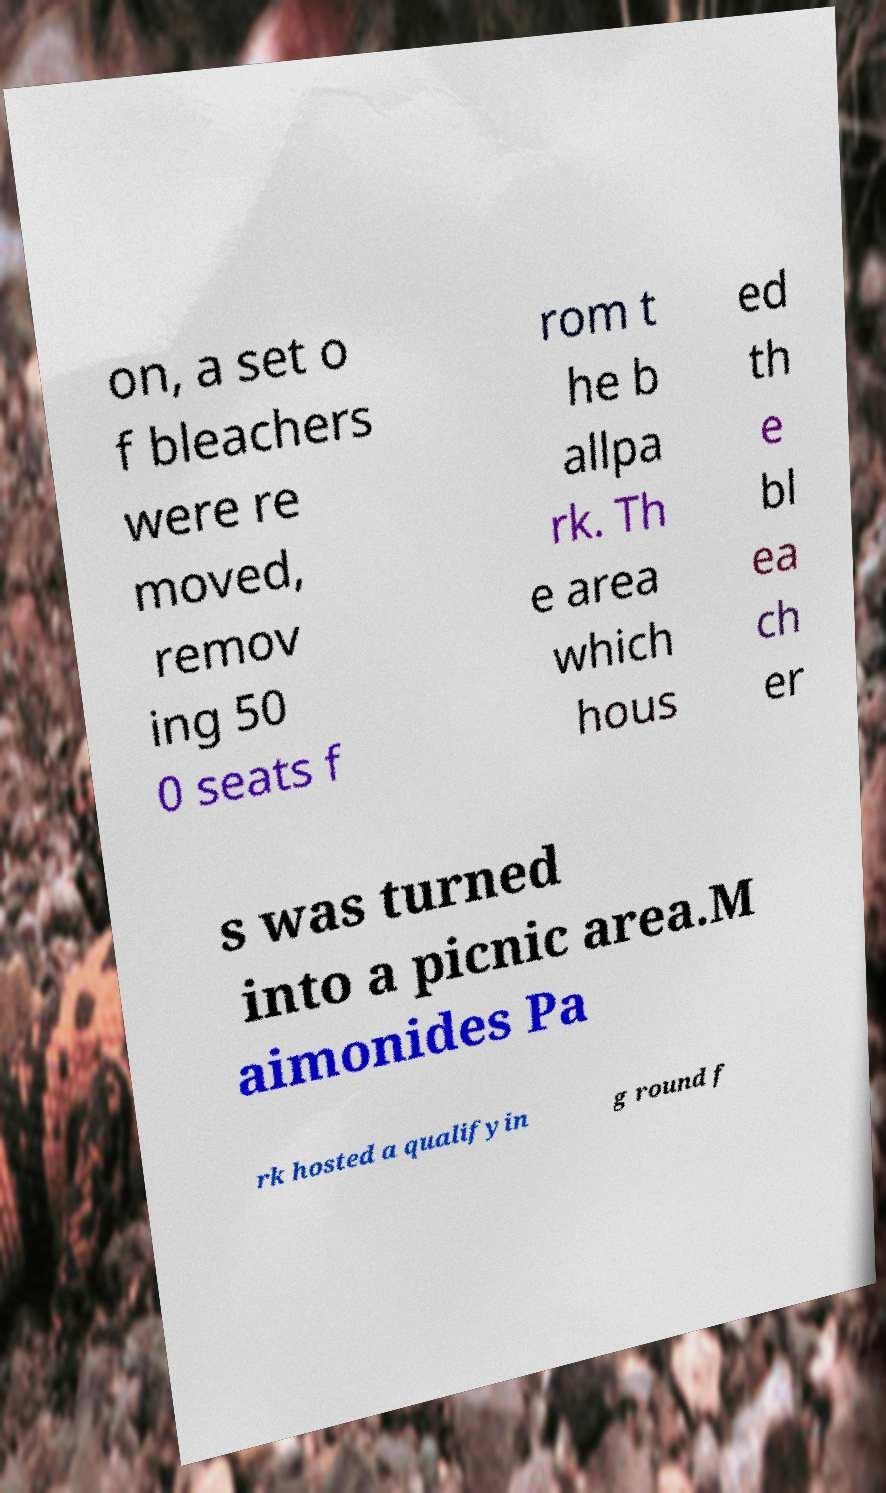I need the written content from this picture converted into text. Can you do that? on, a set o f bleachers were re moved, remov ing 50 0 seats f rom t he b allpa rk. Th e area which hous ed th e bl ea ch er s was turned into a picnic area.M aimonides Pa rk hosted a qualifyin g round f 